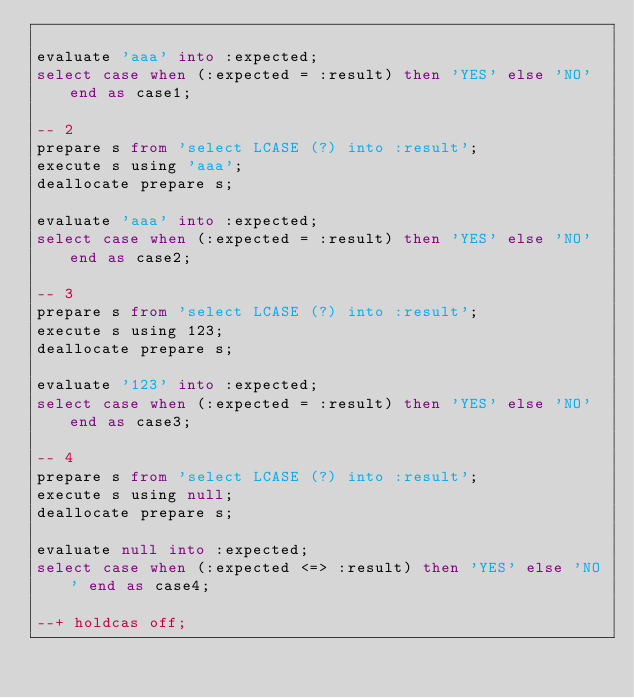<code> <loc_0><loc_0><loc_500><loc_500><_SQL_>
evaluate 'aaa' into :expected;
select case when (:expected = :result) then 'YES' else 'NO' end as case1;

-- 2
prepare s from 'select LCASE (?) into :result';
execute s using 'aaa';
deallocate prepare s;

evaluate 'aaa' into :expected;
select case when (:expected = :result) then 'YES' else 'NO' end as case2;

-- 3
prepare s from 'select LCASE (?) into :result';
execute s using 123;
deallocate prepare s;

evaluate '123' into :expected;
select case when (:expected = :result) then 'YES' else 'NO' end as case3;

-- 4
prepare s from 'select LCASE (?) into :result';
execute s using null;
deallocate prepare s;

evaluate null into :expected;
select case when (:expected <=> :result) then 'YES' else 'NO' end as case4;

--+ holdcas off;
</code> 